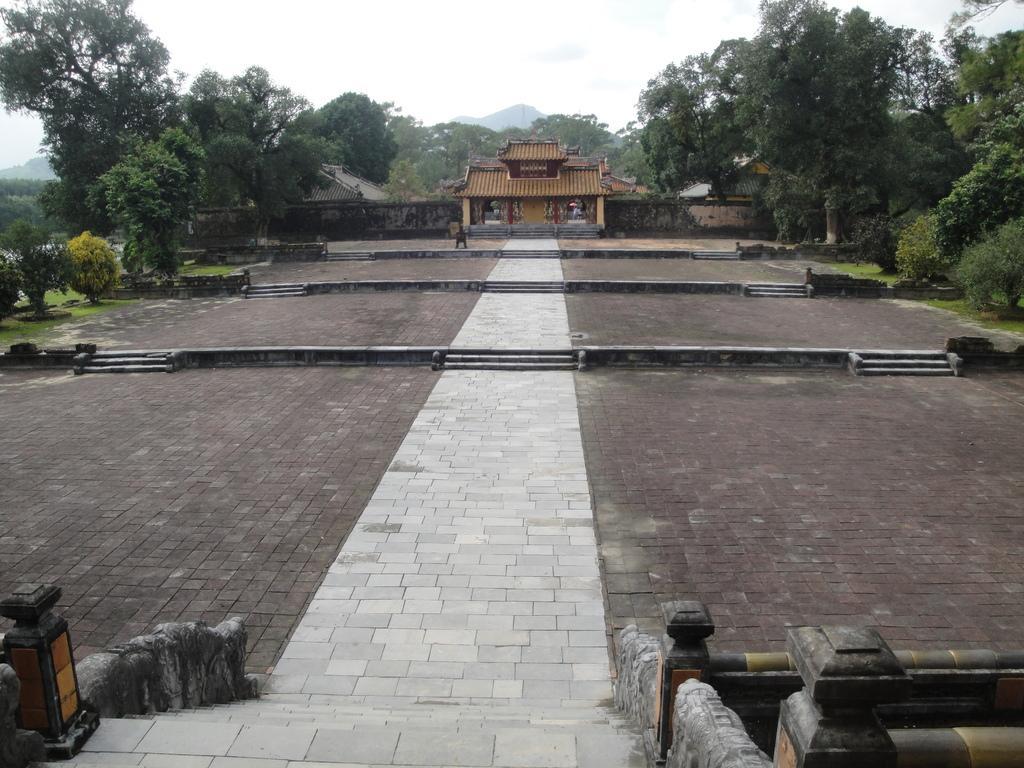In one or two sentences, can you explain what this image depicts? In this image we can see the mountains, some houses, one statue, one temple, some pillars, some objects in the house, some trees, bushes, plants and grass on the ground. At the top there is the sky. 